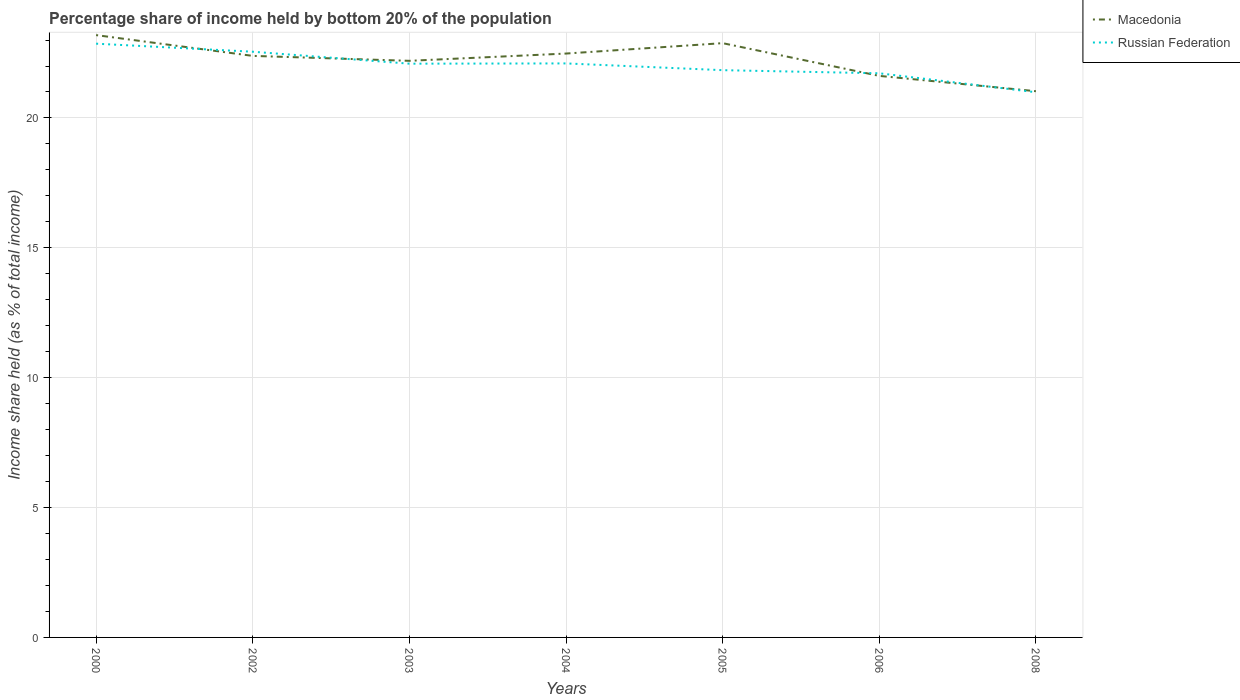Is the number of lines equal to the number of legend labels?
Ensure brevity in your answer.  Yes. Across all years, what is the maximum share of income held by bottom 20% of the population in Russian Federation?
Your answer should be compact. 20.99. What is the total share of income held by bottom 20% of the population in Macedonia in the graph?
Provide a short and direct response. 0.99. What is the difference between the highest and the second highest share of income held by bottom 20% of the population in Russian Federation?
Provide a short and direct response. 1.87. How many years are there in the graph?
Provide a succinct answer. 7. Are the values on the major ticks of Y-axis written in scientific E-notation?
Offer a very short reply. No. Does the graph contain any zero values?
Your response must be concise. No. Does the graph contain grids?
Provide a short and direct response. Yes. What is the title of the graph?
Your answer should be compact. Percentage share of income held by bottom 20% of the population. Does "Peru" appear as one of the legend labels in the graph?
Provide a succinct answer. No. What is the label or title of the X-axis?
Provide a short and direct response. Years. What is the label or title of the Y-axis?
Offer a terse response. Income share held (as % of total income). What is the Income share held (as % of total income) in Macedonia in 2000?
Provide a short and direct response. 23.19. What is the Income share held (as % of total income) of Russian Federation in 2000?
Ensure brevity in your answer.  22.86. What is the Income share held (as % of total income) in Macedonia in 2002?
Ensure brevity in your answer.  22.39. What is the Income share held (as % of total income) in Russian Federation in 2002?
Provide a succinct answer. 22.55. What is the Income share held (as % of total income) in Macedonia in 2003?
Provide a succinct answer. 22.2. What is the Income share held (as % of total income) of Russian Federation in 2003?
Make the answer very short. 22.09. What is the Income share held (as % of total income) of Macedonia in 2004?
Offer a terse response. 22.48. What is the Income share held (as % of total income) in Russian Federation in 2004?
Provide a short and direct response. 22.1. What is the Income share held (as % of total income) of Macedonia in 2005?
Your response must be concise. 22.88. What is the Income share held (as % of total income) of Russian Federation in 2005?
Make the answer very short. 21.84. What is the Income share held (as % of total income) of Macedonia in 2006?
Provide a succinct answer. 21.62. What is the Income share held (as % of total income) in Russian Federation in 2006?
Offer a terse response. 21.72. What is the Income share held (as % of total income) in Macedonia in 2008?
Provide a succinct answer. 21.03. What is the Income share held (as % of total income) of Russian Federation in 2008?
Make the answer very short. 20.99. Across all years, what is the maximum Income share held (as % of total income) in Macedonia?
Keep it short and to the point. 23.19. Across all years, what is the maximum Income share held (as % of total income) of Russian Federation?
Give a very brief answer. 22.86. Across all years, what is the minimum Income share held (as % of total income) in Macedonia?
Provide a succinct answer. 21.03. Across all years, what is the minimum Income share held (as % of total income) of Russian Federation?
Ensure brevity in your answer.  20.99. What is the total Income share held (as % of total income) in Macedonia in the graph?
Make the answer very short. 155.79. What is the total Income share held (as % of total income) of Russian Federation in the graph?
Offer a very short reply. 154.15. What is the difference between the Income share held (as % of total income) in Russian Federation in 2000 and that in 2002?
Offer a very short reply. 0.31. What is the difference between the Income share held (as % of total income) of Macedonia in 2000 and that in 2003?
Make the answer very short. 0.99. What is the difference between the Income share held (as % of total income) in Russian Federation in 2000 and that in 2003?
Offer a terse response. 0.77. What is the difference between the Income share held (as % of total income) of Macedonia in 2000 and that in 2004?
Offer a terse response. 0.71. What is the difference between the Income share held (as % of total income) in Russian Federation in 2000 and that in 2004?
Keep it short and to the point. 0.76. What is the difference between the Income share held (as % of total income) in Macedonia in 2000 and that in 2005?
Provide a short and direct response. 0.31. What is the difference between the Income share held (as % of total income) in Macedonia in 2000 and that in 2006?
Your answer should be very brief. 1.57. What is the difference between the Income share held (as % of total income) of Russian Federation in 2000 and that in 2006?
Keep it short and to the point. 1.14. What is the difference between the Income share held (as % of total income) of Macedonia in 2000 and that in 2008?
Ensure brevity in your answer.  2.16. What is the difference between the Income share held (as % of total income) of Russian Federation in 2000 and that in 2008?
Give a very brief answer. 1.87. What is the difference between the Income share held (as % of total income) in Macedonia in 2002 and that in 2003?
Give a very brief answer. 0.19. What is the difference between the Income share held (as % of total income) in Russian Federation in 2002 and that in 2003?
Ensure brevity in your answer.  0.46. What is the difference between the Income share held (as % of total income) in Macedonia in 2002 and that in 2004?
Offer a very short reply. -0.09. What is the difference between the Income share held (as % of total income) of Russian Federation in 2002 and that in 2004?
Offer a terse response. 0.45. What is the difference between the Income share held (as % of total income) in Macedonia in 2002 and that in 2005?
Keep it short and to the point. -0.49. What is the difference between the Income share held (as % of total income) of Russian Federation in 2002 and that in 2005?
Your answer should be very brief. 0.71. What is the difference between the Income share held (as % of total income) in Macedonia in 2002 and that in 2006?
Make the answer very short. 0.77. What is the difference between the Income share held (as % of total income) in Russian Federation in 2002 and that in 2006?
Your answer should be compact. 0.83. What is the difference between the Income share held (as % of total income) of Macedonia in 2002 and that in 2008?
Make the answer very short. 1.36. What is the difference between the Income share held (as % of total income) in Russian Federation in 2002 and that in 2008?
Your answer should be very brief. 1.56. What is the difference between the Income share held (as % of total income) of Macedonia in 2003 and that in 2004?
Ensure brevity in your answer.  -0.28. What is the difference between the Income share held (as % of total income) of Russian Federation in 2003 and that in 2004?
Offer a terse response. -0.01. What is the difference between the Income share held (as % of total income) in Macedonia in 2003 and that in 2005?
Provide a succinct answer. -0.68. What is the difference between the Income share held (as % of total income) in Russian Federation in 2003 and that in 2005?
Make the answer very short. 0.25. What is the difference between the Income share held (as % of total income) in Macedonia in 2003 and that in 2006?
Ensure brevity in your answer.  0.58. What is the difference between the Income share held (as % of total income) of Russian Federation in 2003 and that in 2006?
Your answer should be compact. 0.37. What is the difference between the Income share held (as % of total income) in Macedonia in 2003 and that in 2008?
Provide a succinct answer. 1.17. What is the difference between the Income share held (as % of total income) of Russian Federation in 2003 and that in 2008?
Offer a very short reply. 1.1. What is the difference between the Income share held (as % of total income) in Macedonia in 2004 and that in 2005?
Give a very brief answer. -0.4. What is the difference between the Income share held (as % of total income) in Russian Federation in 2004 and that in 2005?
Provide a short and direct response. 0.26. What is the difference between the Income share held (as % of total income) in Macedonia in 2004 and that in 2006?
Your answer should be compact. 0.86. What is the difference between the Income share held (as % of total income) in Russian Federation in 2004 and that in 2006?
Provide a succinct answer. 0.38. What is the difference between the Income share held (as % of total income) of Macedonia in 2004 and that in 2008?
Provide a succinct answer. 1.45. What is the difference between the Income share held (as % of total income) of Russian Federation in 2004 and that in 2008?
Provide a short and direct response. 1.11. What is the difference between the Income share held (as % of total income) in Macedonia in 2005 and that in 2006?
Your response must be concise. 1.26. What is the difference between the Income share held (as % of total income) in Russian Federation in 2005 and that in 2006?
Make the answer very short. 0.12. What is the difference between the Income share held (as % of total income) of Macedonia in 2005 and that in 2008?
Provide a short and direct response. 1.85. What is the difference between the Income share held (as % of total income) of Russian Federation in 2005 and that in 2008?
Your response must be concise. 0.85. What is the difference between the Income share held (as % of total income) in Macedonia in 2006 and that in 2008?
Provide a succinct answer. 0.59. What is the difference between the Income share held (as % of total income) in Russian Federation in 2006 and that in 2008?
Your answer should be compact. 0.73. What is the difference between the Income share held (as % of total income) in Macedonia in 2000 and the Income share held (as % of total income) in Russian Federation in 2002?
Keep it short and to the point. 0.64. What is the difference between the Income share held (as % of total income) in Macedonia in 2000 and the Income share held (as % of total income) in Russian Federation in 2004?
Keep it short and to the point. 1.09. What is the difference between the Income share held (as % of total income) in Macedonia in 2000 and the Income share held (as % of total income) in Russian Federation in 2005?
Your answer should be compact. 1.35. What is the difference between the Income share held (as % of total income) of Macedonia in 2000 and the Income share held (as % of total income) of Russian Federation in 2006?
Your answer should be compact. 1.47. What is the difference between the Income share held (as % of total income) of Macedonia in 2000 and the Income share held (as % of total income) of Russian Federation in 2008?
Your answer should be compact. 2.2. What is the difference between the Income share held (as % of total income) of Macedonia in 2002 and the Income share held (as % of total income) of Russian Federation in 2003?
Give a very brief answer. 0.3. What is the difference between the Income share held (as % of total income) of Macedonia in 2002 and the Income share held (as % of total income) of Russian Federation in 2004?
Make the answer very short. 0.29. What is the difference between the Income share held (as % of total income) in Macedonia in 2002 and the Income share held (as % of total income) in Russian Federation in 2005?
Offer a very short reply. 0.55. What is the difference between the Income share held (as % of total income) of Macedonia in 2002 and the Income share held (as % of total income) of Russian Federation in 2006?
Your answer should be very brief. 0.67. What is the difference between the Income share held (as % of total income) in Macedonia in 2002 and the Income share held (as % of total income) in Russian Federation in 2008?
Your answer should be compact. 1.4. What is the difference between the Income share held (as % of total income) in Macedonia in 2003 and the Income share held (as % of total income) in Russian Federation in 2004?
Offer a terse response. 0.1. What is the difference between the Income share held (as % of total income) in Macedonia in 2003 and the Income share held (as % of total income) in Russian Federation in 2005?
Keep it short and to the point. 0.36. What is the difference between the Income share held (as % of total income) of Macedonia in 2003 and the Income share held (as % of total income) of Russian Federation in 2006?
Your answer should be compact. 0.48. What is the difference between the Income share held (as % of total income) in Macedonia in 2003 and the Income share held (as % of total income) in Russian Federation in 2008?
Offer a terse response. 1.21. What is the difference between the Income share held (as % of total income) of Macedonia in 2004 and the Income share held (as % of total income) of Russian Federation in 2005?
Your answer should be compact. 0.64. What is the difference between the Income share held (as % of total income) in Macedonia in 2004 and the Income share held (as % of total income) in Russian Federation in 2006?
Provide a short and direct response. 0.76. What is the difference between the Income share held (as % of total income) of Macedonia in 2004 and the Income share held (as % of total income) of Russian Federation in 2008?
Offer a very short reply. 1.49. What is the difference between the Income share held (as % of total income) of Macedonia in 2005 and the Income share held (as % of total income) of Russian Federation in 2006?
Give a very brief answer. 1.16. What is the difference between the Income share held (as % of total income) of Macedonia in 2005 and the Income share held (as % of total income) of Russian Federation in 2008?
Your response must be concise. 1.89. What is the difference between the Income share held (as % of total income) in Macedonia in 2006 and the Income share held (as % of total income) in Russian Federation in 2008?
Make the answer very short. 0.63. What is the average Income share held (as % of total income) of Macedonia per year?
Provide a succinct answer. 22.26. What is the average Income share held (as % of total income) of Russian Federation per year?
Your answer should be compact. 22.02. In the year 2000, what is the difference between the Income share held (as % of total income) in Macedonia and Income share held (as % of total income) in Russian Federation?
Keep it short and to the point. 0.33. In the year 2002, what is the difference between the Income share held (as % of total income) of Macedonia and Income share held (as % of total income) of Russian Federation?
Your answer should be very brief. -0.16. In the year 2003, what is the difference between the Income share held (as % of total income) in Macedonia and Income share held (as % of total income) in Russian Federation?
Give a very brief answer. 0.11. In the year 2004, what is the difference between the Income share held (as % of total income) in Macedonia and Income share held (as % of total income) in Russian Federation?
Keep it short and to the point. 0.38. In the year 2006, what is the difference between the Income share held (as % of total income) in Macedonia and Income share held (as % of total income) in Russian Federation?
Keep it short and to the point. -0.1. What is the ratio of the Income share held (as % of total income) in Macedonia in 2000 to that in 2002?
Your response must be concise. 1.04. What is the ratio of the Income share held (as % of total income) in Russian Federation in 2000 to that in 2002?
Your answer should be compact. 1.01. What is the ratio of the Income share held (as % of total income) of Macedonia in 2000 to that in 2003?
Ensure brevity in your answer.  1.04. What is the ratio of the Income share held (as % of total income) in Russian Federation in 2000 to that in 2003?
Give a very brief answer. 1.03. What is the ratio of the Income share held (as % of total income) of Macedonia in 2000 to that in 2004?
Ensure brevity in your answer.  1.03. What is the ratio of the Income share held (as % of total income) in Russian Federation in 2000 to that in 2004?
Offer a very short reply. 1.03. What is the ratio of the Income share held (as % of total income) of Macedonia in 2000 to that in 2005?
Keep it short and to the point. 1.01. What is the ratio of the Income share held (as % of total income) of Russian Federation in 2000 to that in 2005?
Give a very brief answer. 1.05. What is the ratio of the Income share held (as % of total income) of Macedonia in 2000 to that in 2006?
Ensure brevity in your answer.  1.07. What is the ratio of the Income share held (as % of total income) of Russian Federation in 2000 to that in 2006?
Make the answer very short. 1.05. What is the ratio of the Income share held (as % of total income) of Macedonia in 2000 to that in 2008?
Provide a short and direct response. 1.1. What is the ratio of the Income share held (as % of total income) of Russian Federation in 2000 to that in 2008?
Offer a terse response. 1.09. What is the ratio of the Income share held (as % of total income) in Macedonia in 2002 to that in 2003?
Ensure brevity in your answer.  1.01. What is the ratio of the Income share held (as % of total income) in Russian Federation in 2002 to that in 2003?
Provide a short and direct response. 1.02. What is the ratio of the Income share held (as % of total income) of Russian Federation in 2002 to that in 2004?
Your answer should be very brief. 1.02. What is the ratio of the Income share held (as % of total income) in Macedonia in 2002 to that in 2005?
Provide a short and direct response. 0.98. What is the ratio of the Income share held (as % of total income) of Russian Federation in 2002 to that in 2005?
Your answer should be compact. 1.03. What is the ratio of the Income share held (as % of total income) in Macedonia in 2002 to that in 2006?
Provide a succinct answer. 1.04. What is the ratio of the Income share held (as % of total income) of Russian Federation in 2002 to that in 2006?
Make the answer very short. 1.04. What is the ratio of the Income share held (as % of total income) of Macedonia in 2002 to that in 2008?
Provide a succinct answer. 1.06. What is the ratio of the Income share held (as % of total income) in Russian Federation in 2002 to that in 2008?
Provide a succinct answer. 1.07. What is the ratio of the Income share held (as % of total income) in Macedonia in 2003 to that in 2004?
Provide a short and direct response. 0.99. What is the ratio of the Income share held (as % of total income) in Russian Federation in 2003 to that in 2004?
Keep it short and to the point. 1. What is the ratio of the Income share held (as % of total income) of Macedonia in 2003 to that in 2005?
Keep it short and to the point. 0.97. What is the ratio of the Income share held (as % of total income) of Russian Federation in 2003 to that in 2005?
Provide a succinct answer. 1.01. What is the ratio of the Income share held (as % of total income) of Macedonia in 2003 to that in 2006?
Your answer should be compact. 1.03. What is the ratio of the Income share held (as % of total income) of Russian Federation in 2003 to that in 2006?
Ensure brevity in your answer.  1.02. What is the ratio of the Income share held (as % of total income) of Macedonia in 2003 to that in 2008?
Provide a succinct answer. 1.06. What is the ratio of the Income share held (as % of total income) of Russian Federation in 2003 to that in 2008?
Provide a succinct answer. 1.05. What is the ratio of the Income share held (as % of total income) in Macedonia in 2004 to that in 2005?
Offer a terse response. 0.98. What is the ratio of the Income share held (as % of total income) in Russian Federation in 2004 to that in 2005?
Your response must be concise. 1.01. What is the ratio of the Income share held (as % of total income) of Macedonia in 2004 to that in 2006?
Your response must be concise. 1.04. What is the ratio of the Income share held (as % of total income) in Russian Federation in 2004 to that in 2006?
Your answer should be very brief. 1.02. What is the ratio of the Income share held (as % of total income) of Macedonia in 2004 to that in 2008?
Provide a succinct answer. 1.07. What is the ratio of the Income share held (as % of total income) in Russian Federation in 2004 to that in 2008?
Your answer should be compact. 1.05. What is the ratio of the Income share held (as % of total income) in Macedonia in 2005 to that in 2006?
Provide a succinct answer. 1.06. What is the ratio of the Income share held (as % of total income) of Macedonia in 2005 to that in 2008?
Your answer should be very brief. 1.09. What is the ratio of the Income share held (as % of total income) of Russian Federation in 2005 to that in 2008?
Offer a terse response. 1.04. What is the ratio of the Income share held (as % of total income) of Macedonia in 2006 to that in 2008?
Give a very brief answer. 1.03. What is the ratio of the Income share held (as % of total income) in Russian Federation in 2006 to that in 2008?
Provide a short and direct response. 1.03. What is the difference between the highest and the second highest Income share held (as % of total income) in Macedonia?
Provide a succinct answer. 0.31. What is the difference between the highest and the second highest Income share held (as % of total income) in Russian Federation?
Make the answer very short. 0.31. What is the difference between the highest and the lowest Income share held (as % of total income) in Macedonia?
Your answer should be compact. 2.16. What is the difference between the highest and the lowest Income share held (as % of total income) of Russian Federation?
Provide a short and direct response. 1.87. 